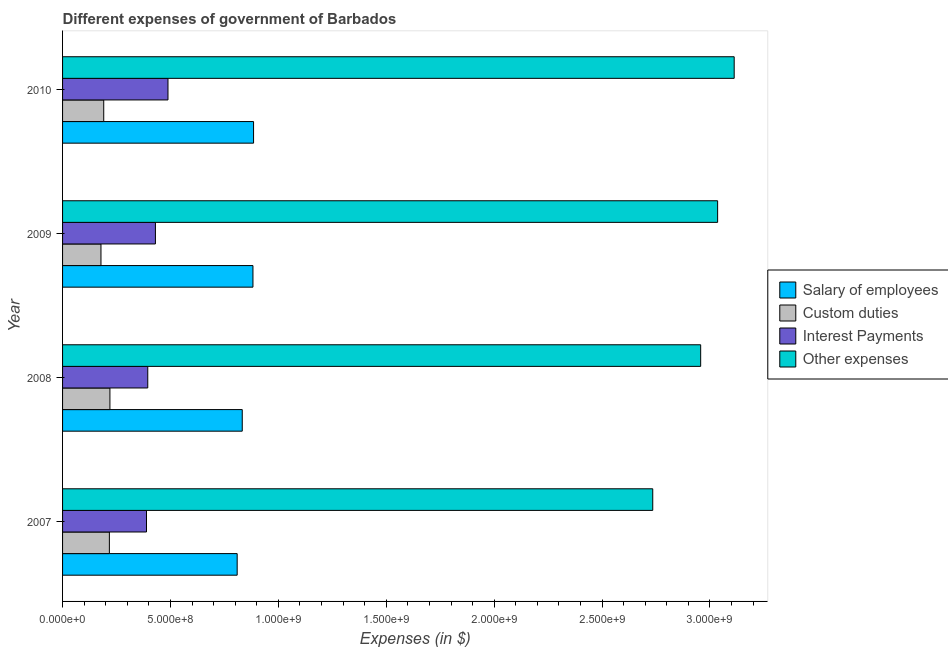Are the number of bars per tick equal to the number of legend labels?
Make the answer very short. Yes. Are the number of bars on each tick of the Y-axis equal?
Provide a short and direct response. Yes. How many bars are there on the 4th tick from the top?
Offer a very short reply. 4. What is the label of the 2nd group of bars from the top?
Provide a short and direct response. 2009. What is the amount spent on interest payments in 2008?
Your answer should be very brief. 3.95e+08. Across all years, what is the maximum amount spent on other expenses?
Keep it short and to the point. 3.11e+09. Across all years, what is the minimum amount spent on other expenses?
Your answer should be very brief. 2.73e+09. In which year was the amount spent on interest payments minimum?
Provide a short and direct response. 2007. What is the total amount spent on interest payments in the graph?
Make the answer very short. 1.70e+09. What is the difference between the amount spent on salary of employees in 2008 and that in 2010?
Offer a terse response. -5.24e+07. What is the difference between the amount spent on other expenses in 2010 and the amount spent on salary of employees in 2008?
Offer a very short reply. 2.28e+09. What is the average amount spent on interest payments per year?
Offer a terse response. 4.26e+08. In the year 2010, what is the difference between the amount spent on interest payments and amount spent on custom duties?
Ensure brevity in your answer.  2.98e+08. What is the ratio of the amount spent on custom duties in 2008 to that in 2010?
Provide a short and direct response. 1.15. Is the amount spent on salary of employees in 2007 less than that in 2008?
Your response must be concise. Yes. What is the difference between the highest and the second highest amount spent on interest payments?
Your answer should be very brief. 5.82e+07. What is the difference between the highest and the lowest amount spent on interest payments?
Keep it short and to the point. 9.95e+07. Is the sum of the amount spent on other expenses in 2007 and 2010 greater than the maximum amount spent on custom duties across all years?
Your response must be concise. Yes. What does the 2nd bar from the top in 2010 represents?
Your response must be concise. Interest Payments. What does the 1st bar from the bottom in 2009 represents?
Give a very brief answer. Salary of employees. How many bars are there?
Your answer should be compact. 16. How many years are there in the graph?
Offer a terse response. 4. What is the difference between two consecutive major ticks on the X-axis?
Offer a terse response. 5.00e+08. Does the graph contain grids?
Ensure brevity in your answer.  No. Where does the legend appear in the graph?
Your answer should be very brief. Center right. How are the legend labels stacked?
Your answer should be very brief. Vertical. What is the title of the graph?
Make the answer very short. Different expenses of government of Barbados. What is the label or title of the X-axis?
Make the answer very short. Expenses (in $). What is the label or title of the Y-axis?
Provide a succinct answer. Year. What is the Expenses (in $) in Salary of employees in 2007?
Ensure brevity in your answer.  8.09e+08. What is the Expenses (in $) of Custom duties in 2007?
Give a very brief answer. 2.17e+08. What is the Expenses (in $) of Interest Payments in 2007?
Make the answer very short. 3.89e+08. What is the Expenses (in $) of Other expenses in 2007?
Offer a very short reply. 2.73e+09. What is the Expenses (in $) in Salary of employees in 2008?
Make the answer very short. 8.33e+08. What is the Expenses (in $) in Custom duties in 2008?
Offer a terse response. 2.19e+08. What is the Expenses (in $) of Interest Payments in 2008?
Your answer should be compact. 3.95e+08. What is the Expenses (in $) in Other expenses in 2008?
Keep it short and to the point. 2.96e+09. What is the Expenses (in $) in Salary of employees in 2009?
Keep it short and to the point. 8.82e+08. What is the Expenses (in $) of Custom duties in 2009?
Keep it short and to the point. 1.78e+08. What is the Expenses (in $) of Interest Payments in 2009?
Make the answer very short. 4.30e+08. What is the Expenses (in $) of Other expenses in 2009?
Keep it short and to the point. 3.04e+09. What is the Expenses (in $) in Salary of employees in 2010?
Ensure brevity in your answer.  8.85e+08. What is the Expenses (in $) of Custom duties in 2010?
Offer a very short reply. 1.91e+08. What is the Expenses (in $) in Interest Payments in 2010?
Your answer should be very brief. 4.88e+08. What is the Expenses (in $) in Other expenses in 2010?
Your response must be concise. 3.11e+09. Across all years, what is the maximum Expenses (in $) of Salary of employees?
Offer a terse response. 8.85e+08. Across all years, what is the maximum Expenses (in $) of Custom duties?
Keep it short and to the point. 2.19e+08. Across all years, what is the maximum Expenses (in $) in Interest Payments?
Offer a terse response. 4.88e+08. Across all years, what is the maximum Expenses (in $) of Other expenses?
Provide a succinct answer. 3.11e+09. Across all years, what is the minimum Expenses (in $) of Salary of employees?
Provide a succinct answer. 8.09e+08. Across all years, what is the minimum Expenses (in $) in Custom duties?
Provide a short and direct response. 1.78e+08. Across all years, what is the minimum Expenses (in $) in Interest Payments?
Make the answer very short. 3.89e+08. Across all years, what is the minimum Expenses (in $) in Other expenses?
Keep it short and to the point. 2.73e+09. What is the total Expenses (in $) in Salary of employees in the graph?
Provide a succinct answer. 3.41e+09. What is the total Expenses (in $) of Custom duties in the graph?
Offer a terse response. 8.05e+08. What is the total Expenses (in $) of Interest Payments in the graph?
Give a very brief answer. 1.70e+09. What is the total Expenses (in $) of Other expenses in the graph?
Your answer should be compact. 1.18e+1. What is the difference between the Expenses (in $) in Salary of employees in 2007 and that in 2008?
Make the answer very short. -2.35e+07. What is the difference between the Expenses (in $) in Custom duties in 2007 and that in 2008?
Make the answer very short. -2.52e+06. What is the difference between the Expenses (in $) of Interest Payments in 2007 and that in 2008?
Make the answer very short. -5.85e+06. What is the difference between the Expenses (in $) in Other expenses in 2007 and that in 2008?
Your answer should be compact. -2.22e+08. What is the difference between the Expenses (in $) of Salary of employees in 2007 and that in 2009?
Keep it short and to the point. -7.31e+07. What is the difference between the Expenses (in $) in Custom duties in 2007 and that in 2009?
Offer a terse response. 3.90e+07. What is the difference between the Expenses (in $) in Interest Payments in 2007 and that in 2009?
Make the answer very short. -4.13e+07. What is the difference between the Expenses (in $) of Other expenses in 2007 and that in 2009?
Provide a succinct answer. -3.01e+08. What is the difference between the Expenses (in $) of Salary of employees in 2007 and that in 2010?
Offer a terse response. -7.60e+07. What is the difference between the Expenses (in $) of Custom duties in 2007 and that in 2010?
Offer a very short reply. 2.61e+07. What is the difference between the Expenses (in $) of Interest Payments in 2007 and that in 2010?
Provide a short and direct response. -9.95e+07. What is the difference between the Expenses (in $) in Other expenses in 2007 and that in 2010?
Offer a very short reply. -3.77e+08. What is the difference between the Expenses (in $) in Salary of employees in 2008 and that in 2009?
Offer a very short reply. -4.96e+07. What is the difference between the Expenses (in $) in Custom duties in 2008 and that in 2009?
Offer a terse response. 4.15e+07. What is the difference between the Expenses (in $) of Interest Payments in 2008 and that in 2009?
Your answer should be compact. -3.55e+07. What is the difference between the Expenses (in $) of Other expenses in 2008 and that in 2009?
Provide a succinct answer. -7.86e+07. What is the difference between the Expenses (in $) of Salary of employees in 2008 and that in 2010?
Your answer should be compact. -5.24e+07. What is the difference between the Expenses (in $) in Custom duties in 2008 and that in 2010?
Your answer should be very brief. 2.87e+07. What is the difference between the Expenses (in $) of Interest Payments in 2008 and that in 2010?
Your answer should be compact. -9.37e+07. What is the difference between the Expenses (in $) of Other expenses in 2008 and that in 2010?
Your answer should be compact. -1.55e+08. What is the difference between the Expenses (in $) in Salary of employees in 2009 and that in 2010?
Your answer should be very brief. -2.85e+06. What is the difference between the Expenses (in $) of Custom duties in 2009 and that in 2010?
Offer a very short reply. -1.28e+07. What is the difference between the Expenses (in $) in Interest Payments in 2009 and that in 2010?
Keep it short and to the point. -5.82e+07. What is the difference between the Expenses (in $) of Other expenses in 2009 and that in 2010?
Give a very brief answer. -7.68e+07. What is the difference between the Expenses (in $) in Salary of employees in 2007 and the Expenses (in $) in Custom duties in 2008?
Your answer should be compact. 5.90e+08. What is the difference between the Expenses (in $) in Salary of employees in 2007 and the Expenses (in $) in Interest Payments in 2008?
Provide a short and direct response. 4.14e+08. What is the difference between the Expenses (in $) in Salary of employees in 2007 and the Expenses (in $) in Other expenses in 2008?
Provide a short and direct response. -2.15e+09. What is the difference between the Expenses (in $) in Custom duties in 2007 and the Expenses (in $) in Interest Payments in 2008?
Provide a short and direct response. -1.78e+08. What is the difference between the Expenses (in $) in Custom duties in 2007 and the Expenses (in $) in Other expenses in 2008?
Give a very brief answer. -2.74e+09. What is the difference between the Expenses (in $) of Interest Payments in 2007 and the Expenses (in $) of Other expenses in 2008?
Give a very brief answer. -2.57e+09. What is the difference between the Expenses (in $) of Salary of employees in 2007 and the Expenses (in $) of Custom duties in 2009?
Make the answer very short. 6.31e+08. What is the difference between the Expenses (in $) in Salary of employees in 2007 and the Expenses (in $) in Interest Payments in 2009?
Keep it short and to the point. 3.79e+08. What is the difference between the Expenses (in $) in Salary of employees in 2007 and the Expenses (in $) in Other expenses in 2009?
Ensure brevity in your answer.  -2.23e+09. What is the difference between the Expenses (in $) in Custom duties in 2007 and the Expenses (in $) in Interest Payments in 2009?
Give a very brief answer. -2.13e+08. What is the difference between the Expenses (in $) of Custom duties in 2007 and the Expenses (in $) of Other expenses in 2009?
Offer a terse response. -2.82e+09. What is the difference between the Expenses (in $) in Interest Payments in 2007 and the Expenses (in $) in Other expenses in 2009?
Your response must be concise. -2.65e+09. What is the difference between the Expenses (in $) in Salary of employees in 2007 and the Expenses (in $) in Custom duties in 2010?
Offer a terse response. 6.18e+08. What is the difference between the Expenses (in $) in Salary of employees in 2007 and the Expenses (in $) in Interest Payments in 2010?
Provide a short and direct response. 3.21e+08. What is the difference between the Expenses (in $) in Salary of employees in 2007 and the Expenses (in $) in Other expenses in 2010?
Keep it short and to the point. -2.30e+09. What is the difference between the Expenses (in $) in Custom duties in 2007 and the Expenses (in $) in Interest Payments in 2010?
Keep it short and to the point. -2.72e+08. What is the difference between the Expenses (in $) in Custom duties in 2007 and the Expenses (in $) in Other expenses in 2010?
Your answer should be very brief. -2.90e+09. What is the difference between the Expenses (in $) of Interest Payments in 2007 and the Expenses (in $) of Other expenses in 2010?
Your response must be concise. -2.72e+09. What is the difference between the Expenses (in $) of Salary of employees in 2008 and the Expenses (in $) of Custom duties in 2009?
Your answer should be very brief. 6.55e+08. What is the difference between the Expenses (in $) of Salary of employees in 2008 and the Expenses (in $) of Interest Payments in 2009?
Keep it short and to the point. 4.02e+08. What is the difference between the Expenses (in $) in Salary of employees in 2008 and the Expenses (in $) in Other expenses in 2009?
Your answer should be compact. -2.20e+09. What is the difference between the Expenses (in $) of Custom duties in 2008 and the Expenses (in $) of Interest Payments in 2009?
Your answer should be compact. -2.11e+08. What is the difference between the Expenses (in $) in Custom duties in 2008 and the Expenses (in $) in Other expenses in 2009?
Offer a very short reply. -2.82e+09. What is the difference between the Expenses (in $) of Interest Payments in 2008 and the Expenses (in $) of Other expenses in 2009?
Your answer should be very brief. -2.64e+09. What is the difference between the Expenses (in $) of Salary of employees in 2008 and the Expenses (in $) of Custom duties in 2010?
Your answer should be compact. 6.42e+08. What is the difference between the Expenses (in $) of Salary of employees in 2008 and the Expenses (in $) of Interest Payments in 2010?
Ensure brevity in your answer.  3.44e+08. What is the difference between the Expenses (in $) of Salary of employees in 2008 and the Expenses (in $) of Other expenses in 2010?
Provide a short and direct response. -2.28e+09. What is the difference between the Expenses (in $) in Custom duties in 2008 and the Expenses (in $) in Interest Payments in 2010?
Offer a very short reply. -2.69e+08. What is the difference between the Expenses (in $) in Custom duties in 2008 and the Expenses (in $) in Other expenses in 2010?
Your response must be concise. -2.89e+09. What is the difference between the Expenses (in $) in Interest Payments in 2008 and the Expenses (in $) in Other expenses in 2010?
Offer a terse response. -2.72e+09. What is the difference between the Expenses (in $) of Salary of employees in 2009 and the Expenses (in $) of Custom duties in 2010?
Give a very brief answer. 6.91e+08. What is the difference between the Expenses (in $) in Salary of employees in 2009 and the Expenses (in $) in Interest Payments in 2010?
Offer a very short reply. 3.94e+08. What is the difference between the Expenses (in $) in Salary of employees in 2009 and the Expenses (in $) in Other expenses in 2010?
Provide a succinct answer. -2.23e+09. What is the difference between the Expenses (in $) of Custom duties in 2009 and the Expenses (in $) of Interest Payments in 2010?
Keep it short and to the point. -3.11e+08. What is the difference between the Expenses (in $) in Custom duties in 2009 and the Expenses (in $) in Other expenses in 2010?
Provide a succinct answer. -2.93e+09. What is the difference between the Expenses (in $) in Interest Payments in 2009 and the Expenses (in $) in Other expenses in 2010?
Your response must be concise. -2.68e+09. What is the average Expenses (in $) of Salary of employees per year?
Make the answer very short. 8.52e+08. What is the average Expenses (in $) in Custom duties per year?
Provide a succinct answer. 2.01e+08. What is the average Expenses (in $) of Interest Payments per year?
Offer a very short reply. 4.26e+08. What is the average Expenses (in $) in Other expenses per year?
Your answer should be compact. 2.96e+09. In the year 2007, what is the difference between the Expenses (in $) of Salary of employees and Expenses (in $) of Custom duties?
Your response must be concise. 5.92e+08. In the year 2007, what is the difference between the Expenses (in $) of Salary of employees and Expenses (in $) of Interest Payments?
Your answer should be very brief. 4.20e+08. In the year 2007, what is the difference between the Expenses (in $) in Salary of employees and Expenses (in $) in Other expenses?
Offer a very short reply. -1.93e+09. In the year 2007, what is the difference between the Expenses (in $) in Custom duties and Expenses (in $) in Interest Payments?
Make the answer very short. -1.72e+08. In the year 2007, what is the difference between the Expenses (in $) in Custom duties and Expenses (in $) in Other expenses?
Provide a succinct answer. -2.52e+09. In the year 2007, what is the difference between the Expenses (in $) in Interest Payments and Expenses (in $) in Other expenses?
Make the answer very short. -2.35e+09. In the year 2008, what is the difference between the Expenses (in $) of Salary of employees and Expenses (in $) of Custom duties?
Your response must be concise. 6.13e+08. In the year 2008, what is the difference between the Expenses (in $) in Salary of employees and Expenses (in $) in Interest Payments?
Ensure brevity in your answer.  4.38e+08. In the year 2008, what is the difference between the Expenses (in $) of Salary of employees and Expenses (in $) of Other expenses?
Provide a short and direct response. -2.12e+09. In the year 2008, what is the difference between the Expenses (in $) of Custom duties and Expenses (in $) of Interest Payments?
Your answer should be very brief. -1.75e+08. In the year 2008, what is the difference between the Expenses (in $) in Custom duties and Expenses (in $) in Other expenses?
Your answer should be very brief. -2.74e+09. In the year 2008, what is the difference between the Expenses (in $) in Interest Payments and Expenses (in $) in Other expenses?
Ensure brevity in your answer.  -2.56e+09. In the year 2009, what is the difference between the Expenses (in $) in Salary of employees and Expenses (in $) in Custom duties?
Your answer should be very brief. 7.04e+08. In the year 2009, what is the difference between the Expenses (in $) of Salary of employees and Expenses (in $) of Interest Payments?
Offer a very short reply. 4.52e+08. In the year 2009, what is the difference between the Expenses (in $) of Salary of employees and Expenses (in $) of Other expenses?
Keep it short and to the point. -2.15e+09. In the year 2009, what is the difference between the Expenses (in $) of Custom duties and Expenses (in $) of Interest Payments?
Give a very brief answer. -2.52e+08. In the year 2009, what is the difference between the Expenses (in $) of Custom duties and Expenses (in $) of Other expenses?
Give a very brief answer. -2.86e+09. In the year 2009, what is the difference between the Expenses (in $) in Interest Payments and Expenses (in $) in Other expenses?
Give a very brief answer. -2.61e+09. In the year 2010, what is the difference between the Expenses (in $) of Salary of employees and Expenses (in $) of Custom duties?
Make the answer very short. 6.94e+08. In the year 2010, what is the difference between the Expenses (in $) of Salary of employees and Expenses (in $) of Interest Payments?
Offer a very short reply. 3.97e+08. In the year 2010, what is the difference between the Expenses (in $) of Salary of employees and Expenses (in $) of Other expenses?
Offer a terse response. -2.23e+09. In the year 2010, what is the difference between the Expenses (in $) in Custom duties and Expenses (in $) in Interest Payments?
Your answer should be very brief. -2.98e+08. In the year 2010, what is the difference between the Expenses (in $) of Custom duties and Expenses (in $) of Other expenses?
Your answer should be compact. -2.92e+09. In the year 2010, what is the difference between the Expenses (in $) in Interest Payments and Expenses (in $) in Other expenses?
Offer a very short reply. -2.62e+09. What is the ratio of the Expenses (in $) in Salary of employees in 2007 to that in 2008?
Give a very brief answer. 0.97. What is the ratio of the Expenses (in $) of Custom duties in 2007 to that in 2008?
Offer a terse response. 0.99. What is the ratio of the Expenses (in $) in Interest Payments in 2007 to that in 2008?
Your answer should be very brief. 0.99. What is the ratio of the Expenses (in $) of Other expenses in 2007 to that in 2008?
Keep it short and to the point. 0.92. What is the ratio of the Expenses (in $) of Salary of employees in 2007 to that in 2009?
Provide a succinct answer. 0.92. What is the ratio of the Expenses (in $) of Custom duties in 2007 to that in 2009?
Offer a very short reply. 1.22. What is the ratio of the Expenses (in $) in Interest Payments in 2007 to that in 2009?
Make the answer very short. 0.9. What is the ratio of the Expenses (in $) of Other expenses in 2007 to that in 2009?
Ensure brevity in your answer.  0.9. What is the ratio of the Expenses (in $) in Salary of employees in 2007 to that in 2010?
Make the answer very short. 0.91. What is the ratio of the Expenses (in $) in Custom duties in 2007 to that in 2010?
Offer a very short reply. 1.14. What is the ratio of the Expenses (in $) of Interest Payments in 2007 to that in 2010?
Offer a very short reply. 0.8. What is the ratio of the Expenses (in $) of Other expenses in 2007 to that in 2010?
Offer a very short reply. 0.88. What is the ratio of the Expenses (in $) of Salary of employees in 2008 to that in 2009?
Your answer should be very brief. 0.94. What is the ratio of the Expenses (in $) in Custom duties in 2008 to that in 2009?
Offer a terse response. 1.23. What is the ratio of the Expenses (in $) in Interest Payments in 2008 to that in 2009?
Make the answer very short. 0.92. What is the ratio of the Expenses (in $) of Other expenses in 2008 to that in 2009?
Give a very brief answer. 0.97. What is the ratio of the Expenses (in $) in Salary of employees in 2008 to that in 2010?
Ensure brevity in your answer.  0.94. What is the ratio of the Expenses (in $) in Custom duties in 2008 to that in 2010?
Make the answer very short. 1.15. What is the ratio of the Expenses (in $) of Interest Payments in 2008 to that in 2010?
Your answer should be compact. 0.81. What is the ratio of the Expenses (in $) in Other expenses in 2008 to that in 2010?
Keep it short and to the point. 0.95. What is the ratio of the Expenses (in $) of Custom duties in 2009 to that in 2010?
Your response must be concise. 0.93. What is the ratio of the Expenses (in $) in Interest Payments in 2009 to that in 2010?
Your answer should be compact. 0.88. What is the ratio of the Expenses (in $) of Other expenses in 2009 to that in 2010?
Provide a succinct answer. 0.98. What is the difference between the highest and the second highest Expenses (in $) of Salary of employees?
Your response must be concise. 2.85e+06. What is the difference between the highest and the second highest Expenses (in $) in Custom duties?
Your response must be concise. 2.52e+06. What is the difference between the highest and the second highest Expenses (in $) in Interest Payments?
Provide a succinct answer. 5.82e+07. What is the difference between the highest and the second highest Expenses (in $) of Other expenses?
Your answer should be very brief. 7.68e+07. What is the difference between the highest and the lowest Expenses (in $) of Salary of employees?
Your response must be concise. 7.60e+07. What is the difference between the highest and the lowest Expenses (in $) in Custom duties?
Offer a terse response. 4.15e+07. What is the difference between the highest and the lowest Expenses (in $) in Interest Payments?
Ensure brevity in your answer.  9.95e+07. What is the difference between the highest and the lowest Expenses (in $) in Other expenses?
Ensure brevity in your answer.  3.77e+08. 